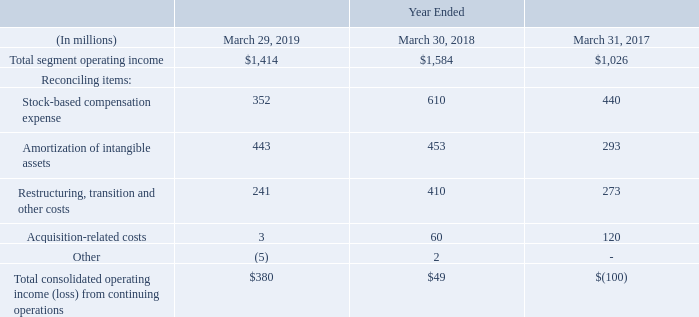We do not allocate to our operating segments certain operating expenses that we manage separately at the corporate level and are not used in evaluating the results of, or in allocating resources to, our segments. These unallocated expenses consist primarily of stock-based compensation expense; amortization of intangible assets; restructuring, transition and other costs; and acquisition-related costs.
The following table provides a reconciliation of our total reportable segments’ operating income to our total operating income (loss):
What do unallocated expenses consist primarily of? Stock-based compensation expense; amortization of intangible assets; restructuring, transition and other costs; and acquisition-related costs. What does this table show? Reconciliation of our total reportable segments’ operating income to our total operating income (loss). What is the Total segment operating income for year ended  March 29, 2019?
Answer scale should be: million. $1,414. What is the average  Total consolidated operating income (loss) from continuing operations for the fiscal years 2019, 2018 and 2017?
Answer scale should be: million. (380+49+(-100))/3
Answer: 109.67. What is  Amortization of intangible assets expressed as a percentage of  Total segment operating income for fiscal year 2019?
Answer scale should be: percent. 443/1,414
Answer: 31.33. What is the  Total consolidated operating income (loss) from continuing operations expressed as a percentage of  Total segment operating income for fiscal year 2019?
Answer scale should be: percent. 380/1,414
Answer: 26.87. 